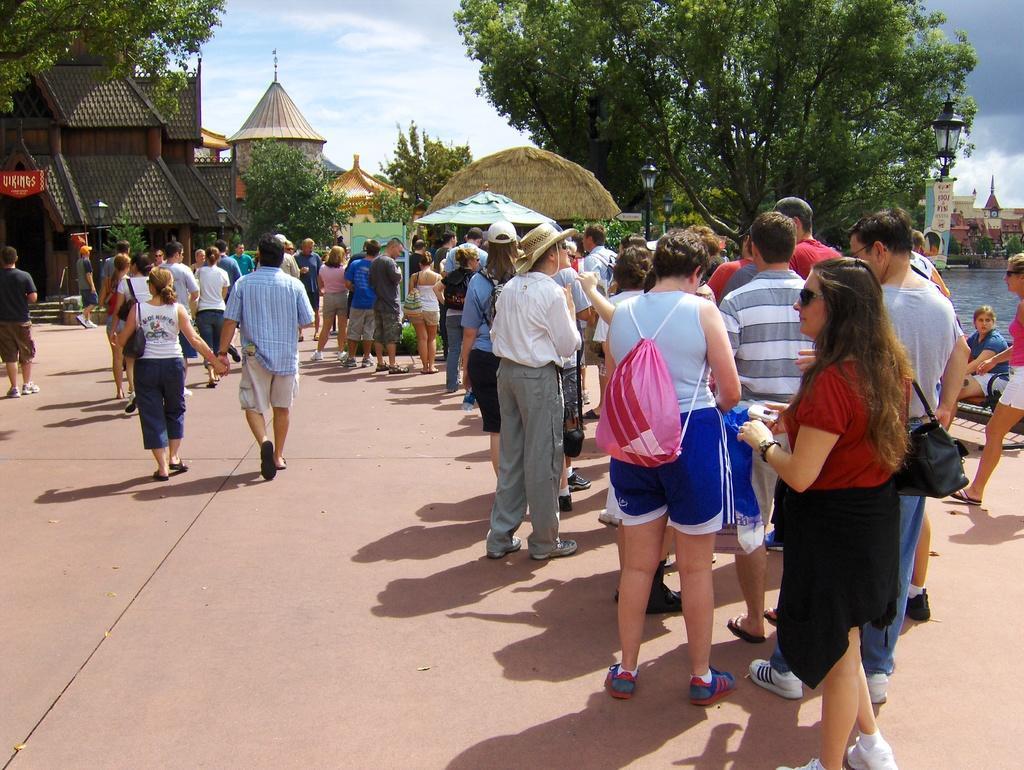In one or two sentences, can you explain what this image depicts? Here people are standing, there are houses and trees, this is sky. 